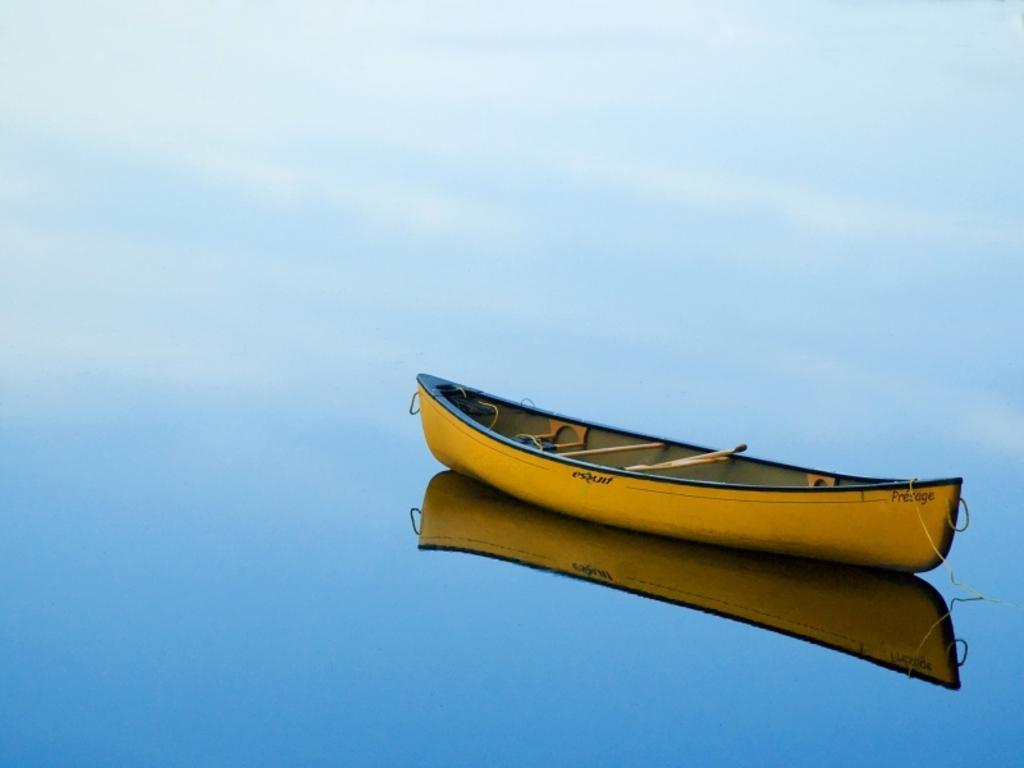Can you describe this image briefly? The picture consists of a boat in a lake. The boat is in yellow color. 